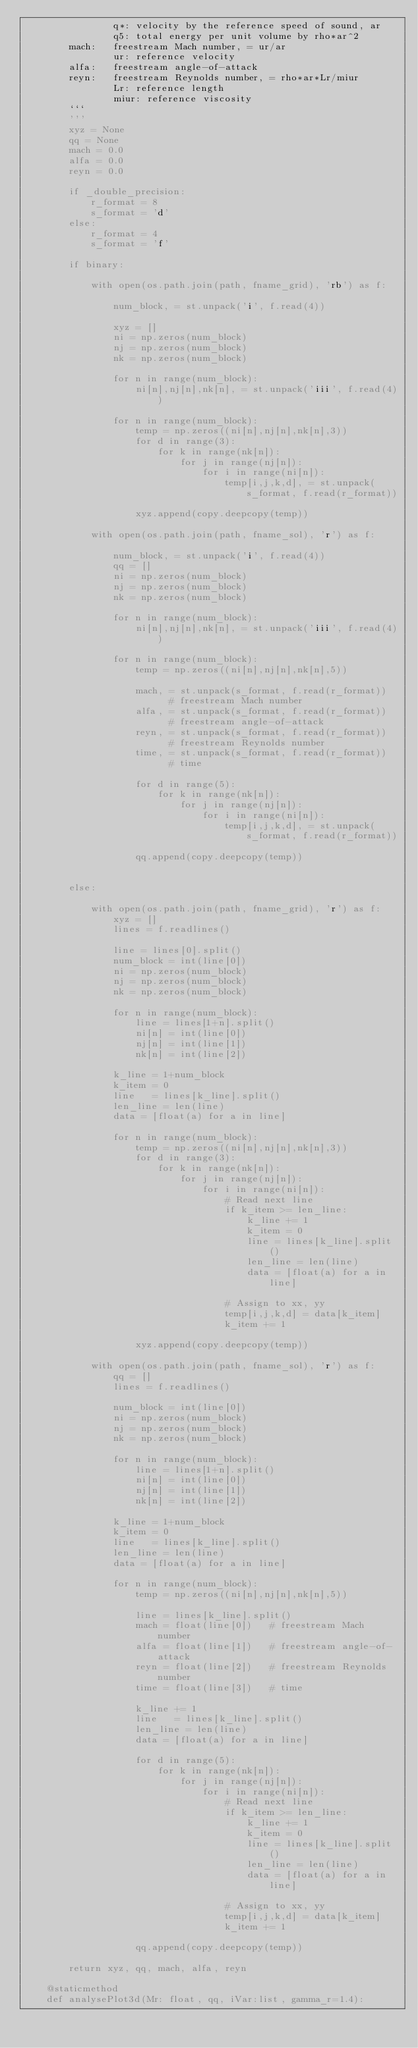<code> <loc_0><loc_0><loc_500><loc_500><_Python_>                q*: velocity by the reference speed of sound, ar
                q5: total energy per unit volume by rho*ar^2
        mach:   freestream Mach number, = ur/ar
                ur: reference velocity
        alfa:   freestream angle-of-attack
        reyn:   freestream Reynolds number, = rho*ar*Lr/miur
                Lr: reference length
                miur: reference viscosity
        ```
        '''
        xyz = None
        qq = None
        mach = 0.0
        alfa = 0.0
        reyn = 0.0

        if _double_precision:
            r_format = 8
            s_format = 'd'
        else:
            r_format = 4
            s_format = 'f'

        if binary:

            with open(os.path.join(path, fname_grid), 'rb') as f:

                num_block, = st.unpack('i', f.read(4))

                xyz = []
                ni = np.zeros(num_block)
                nj = np.zeros(num_block)
                nk = np.zeros(num_block)

                for n in range(num_block):
                    ni[n],nj[n],nk[n], = st.unpack('iii', f.read(4))

                for n in range(num_block):
                    temp = np.zeros((ni[n],nj[n],nk[n],3))
                    for d in range(3):
                        for k in range(nk[n]):
                            for j in range(nj[n]):
                                for i in range(ni[n]):
                                    temp[i,j,k,d], = st.unpack(s_format, f.read(r_format))

                    xyz.append(copy.deepcopy(temp))

            with open(os.path.join(path, fname_sol), 'r') as f:
                
                num_block, = st.unpack('i', f.read(4))
                qq = []
                ni = np.zeros(num_block)
                nj = np.zeros(num_block)
                nk = np.zeros(num_block)

                for n in range(num_block):
                    ni[n],nj[n],nk[n], = st.unpack('iii', f.read(4))

                for n in range(num_block):
                    temp = np.zeros((ni[n],nj[n],nk[n],5))

                    mach, = st.unpack(s_format, f.read(r_format))   # freestream Mach number
                    alfa, = st.unpack(s_format, f.read(r_format))   # freestream angle-of-attack
                    reyn, = st.unpack(s_format, f.read(r_format))   # freestream Reynolds number
                    time, = st.unpack(s_format, f.read(r_format))   # time

                    for d in range(5):
                        for k in range(nk[n]):
                            for j in range(nj[n]):
                                for i in range(ni[n]):
                                    temp[i,j,k,d], = st.unpack(s_format, f.read(r_format))

                    qq.append(copy.deepcopy(temp))


        else:

            with open(os.path.join(path, fname_grid), 'r') as f:
                xyz = []
                lines = f.readlines()

                line = lines[0].split()
                num_block = int(line[0])
                ni = np.zeros(num_block)
                nj = np.zeros(num_block)
                nk = np.zeros(num_block)

                for n in range(num_block):
                    line = lines[1+n].split()
                    ni[n] = int(line[0])
                    nj[n] = int(line[1])
                    nk[n] = int(line[2])

                k_line = 1+num_block
                k_item = 0
                line   = lines[k_line].split()
                len_line = len(line)
                data = [float(a) for a in line]

                for n in range(num_block):
                    temp = np.zeros((ni[n],nj[n],nk[n],3))
                    for d in range(3):
                        for k in range(nk[n]):
                            for j in range(nj[n]):
                                for i in range(ni[n]):
                                    # Read next line
                                    if k_item >= len_line:
                                        k_line += 1
                                        k_item = 0
                                        line = lines[k_line].split()
                                        len_line = len(line)
                                        data = [float(a) for a in line]

                                    # Assign to xx, yy
                                    temp[i,j,k,d] = data[k_item]
                                    k_item += 1

                    xyz.append(copy.deepcopy(temp))

            with open(os.path.join(path, fname_sol), 'r') as f:
                qq = []
                lines = f.readlines()

                num_block = int(line[0])
                ni = np.zeros(num_block)
                nj = np.zeros(num_block)
                nk = np.zeros(num_block)

                for n in range(num_block):
                    line = lines[1+n].split()
                    ni[n] = int(line[0])
                    nj[n] = int(line[1])
                    nk[n] = int(line[2])

                k_line = 1+num_block
                k_item = 0
                line   = lines[k_line].split()
                len_line = len(line)
                data = [float(a) for a in line]

                for n in range(num_block):
                    temp = np.zeros((ni[n],nj[n],nk[n],5))

                    line = lines[k_line].split()
                    mach = float(line[0])   # freestream Mach number
                    alfa = float(line[1])   # freestream angle-of-attack
                    reyn = float(line[2])   # freestream Reynolds number
                    time = float(line[3])   # time

                    k_line += 1
                    line   = lines[k_line].split()
                    len_line = len(line)
                    data = [float(a) for a in line]

                    for d in range(5):
                        for k in range(nk[n]):
                            for j in range(nj[n]):
                                for i in range(ni[n]):
                                    # Read next line
                                    if k_item >= len_line:
                                        k_line += 1
                                        k_item = 0
                                        line = lines[k_line].split()
                                        len_line = len(line)
                                        data = [float(a) for a in line]

                                    # Assign to xx, yy
                                    temp[i,j,k,d] = data[k_item]
                                    k_item += 1

                    qq.append(copy.deepcopy(temp))

        return xyz, qq, mach, alfa, reyn

    @staticmethod
    def analysePlot3d(Mr: float, qq, iVar:list, gamma_r=1.4):</code> 